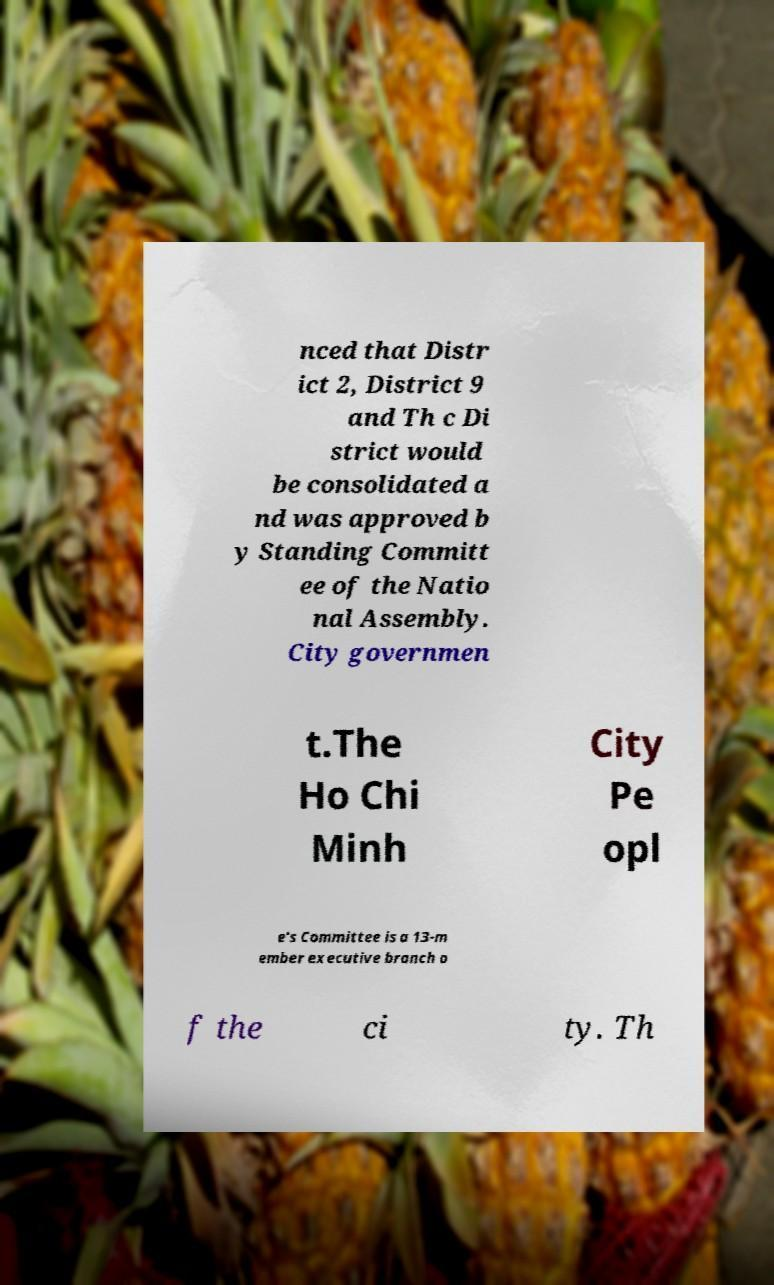Please read and relay the text visible in this image. What does it say? nced that Distr ict 2, District 9 and Th c Di strict would be consolidated a nd was approved b y Standing Committ ee of the Natio nal Assembly. City governmen t.The Ho Chi Minh City Pe opl e's Committee is a 13-m ember executive branch o f the ci ty. Th 